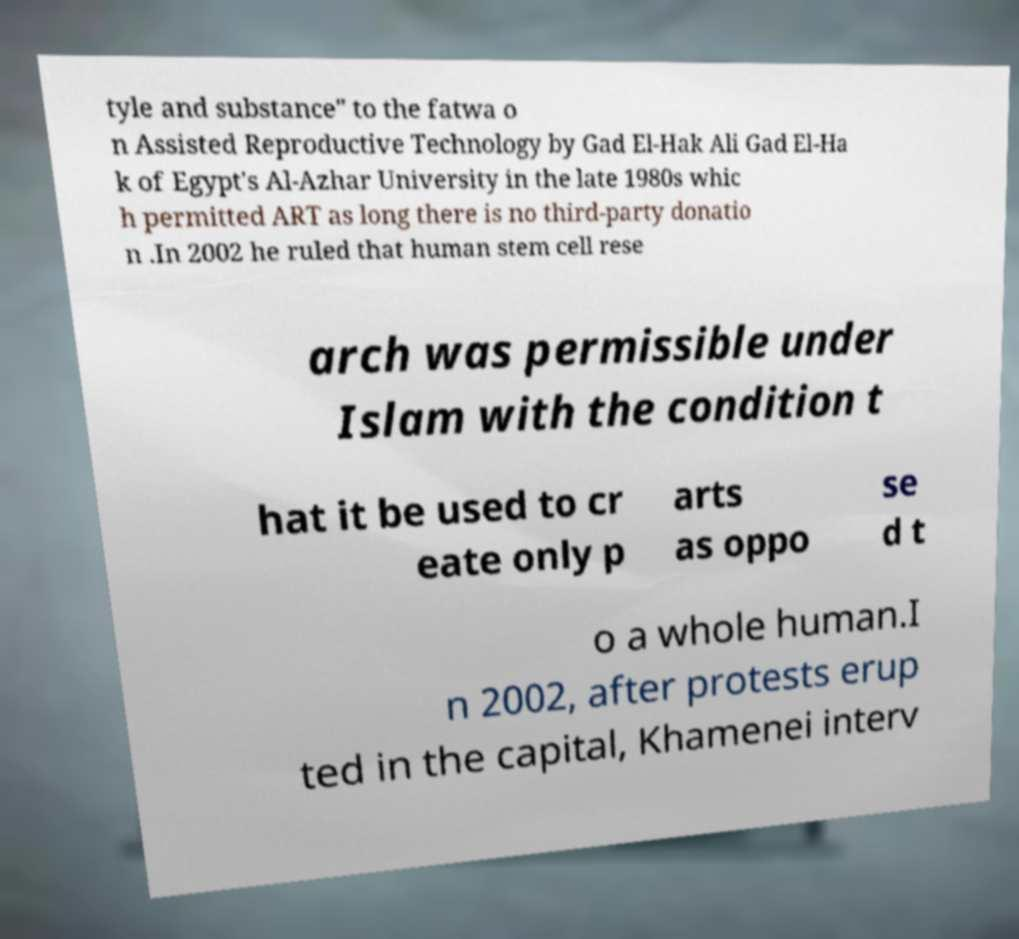Could you assist in decoding the text presented in this image and type it out clearly? tyle and substance" to the fatwa o n Assisted Reproductive Technology by Gad El-Hak Ali Gad El-Ha k of Egypt's Al-Azhar University in the late 1980s whic h permitted ART as long there is no third-party donatio n .In 2002 he ruled that human stem cell rese arch was permissible under Islam with the condition t hat it be used to cr eate only p arts as oppo se d t o a whole human.I n 2002, after protests erup ted in the capital, Khamenei interv 